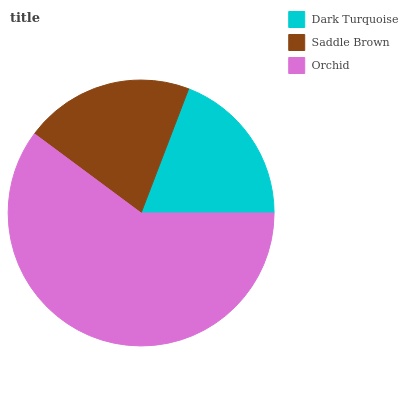Is Dark Turquoise the minimum?
Answer yes or no. Yes. Is Orchid the maximum?
Answer yes or no. Yes. Is Saddle Brown the minimum?
Answer yes or no. No. Is Saddle Brown the maximum?
Answer yes or no. No. Is Saddle Brown greater than Dark Turquoise?
Answer yes or no. Yes. Is Dark Turquoise less than Saddle Brown?
Answer yes or no. Yes. Is Dark Turquoise greater than Saddle Brown?
Answer yes or no. No. Is Saddle Brown less than Dark Turquoise?
Answer yes or no. No. Is Saddle Brown the high median?
Answer yes or no. Yes. Is Saddle Brown the low median?
Answer yes or no. Yes. Is Orchid the high median?
Answer yes or no. No. Is Dark Turquoise the low median?
Answer yes or no. No. 